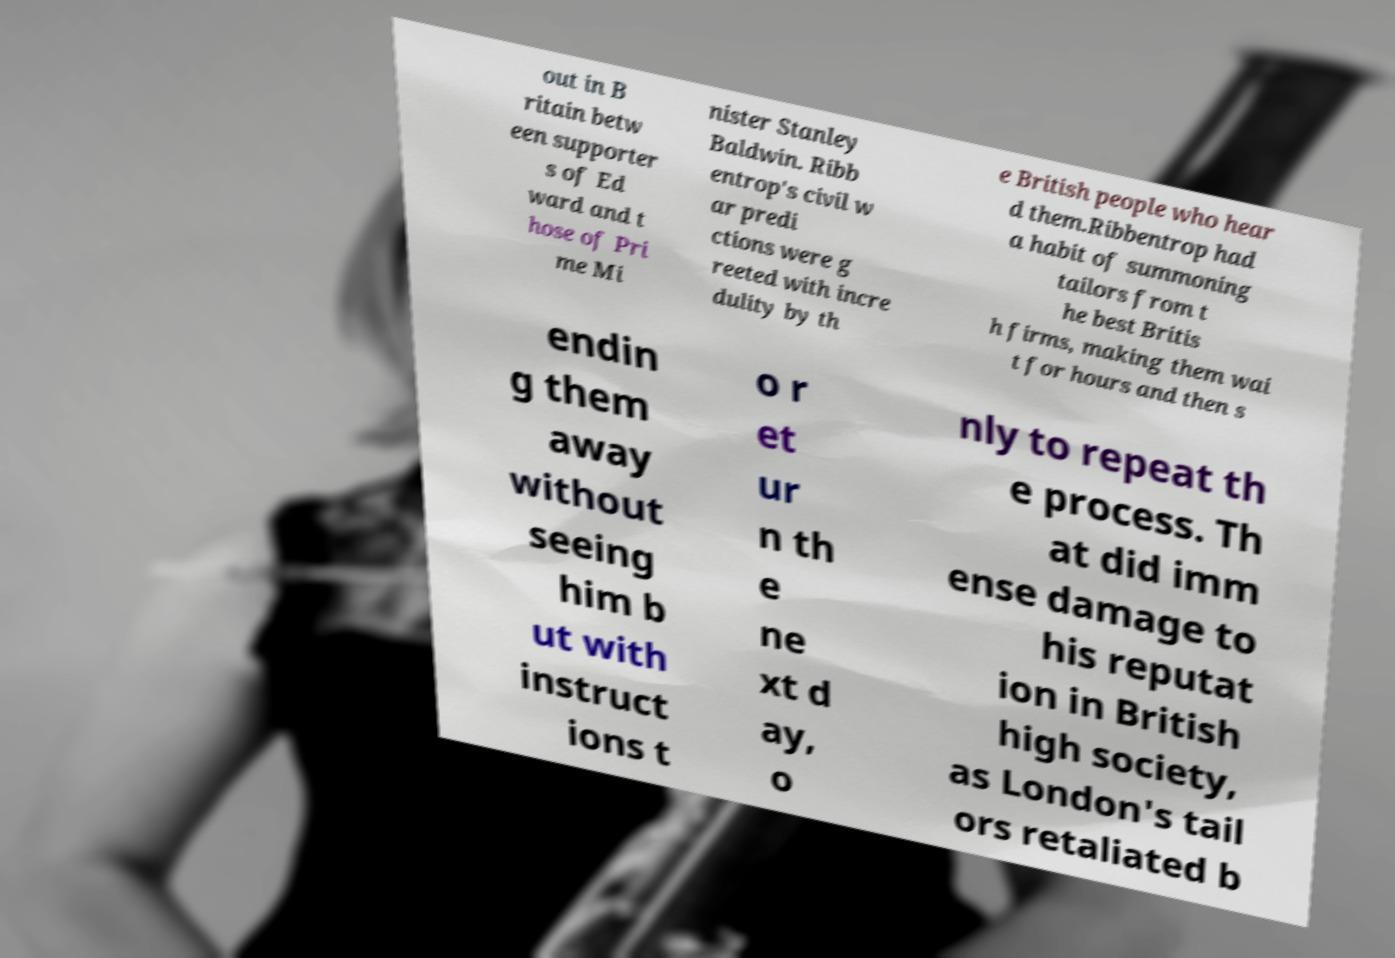Please identify and transcribe the text found in this image. out in B ritain betw een supporter s of Ed ward and t hose of Pri me Mi nister Stanley Baldwin. Ribb entrop's civil w ar predi ctions were g reeted with incre dulity by th e British people who hear d them.Ribbentrop had a habit of summoning tailors from t he best Britis h firms, making them wai t for hours and then s endin g them away without seeing him b ut with instruct ions t o r et ur n th e ne xt d ay, o nly to repeat th e process. Th at did imm ense damage to his reputat ion in British high society, as London's tail ors retaliated b 